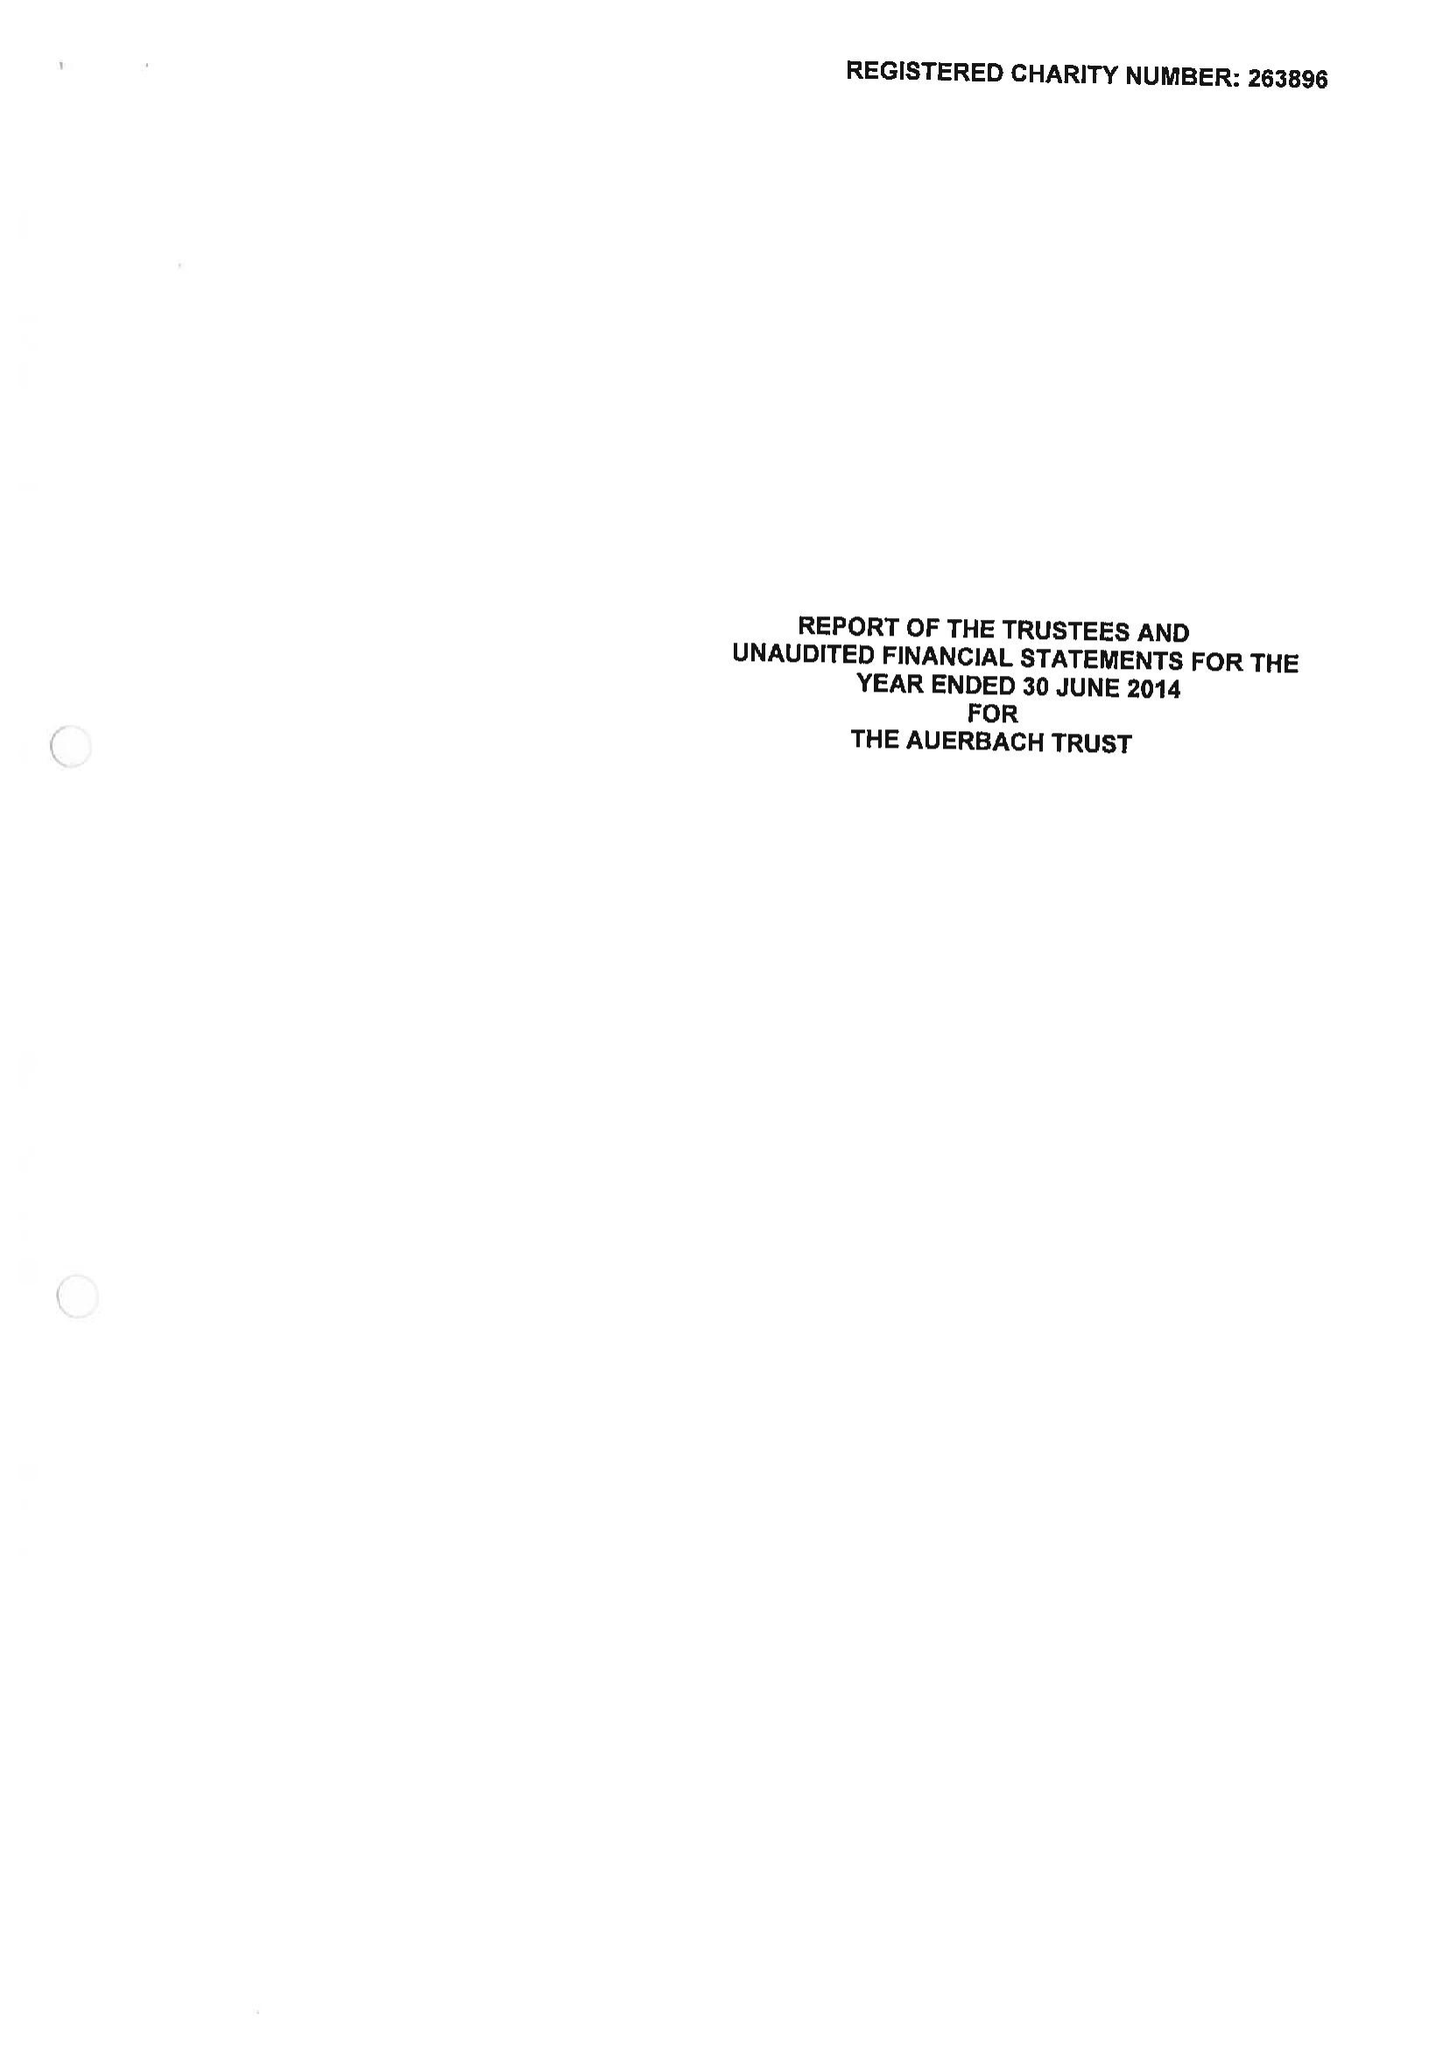What is the value for the charity_number?
Answer the question using a single word or phrase. 263896 